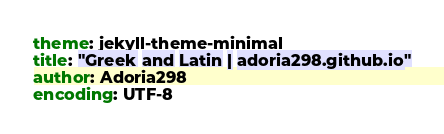Convert code to text. <code><loc_0><loc_0><loc_500><loc_500><_YAML_>theme: jekyll-theme-minimal
title: "Greek and Latin | adoria298.github.io"
author: Adoria298
encoding: UTF-8
</code> 